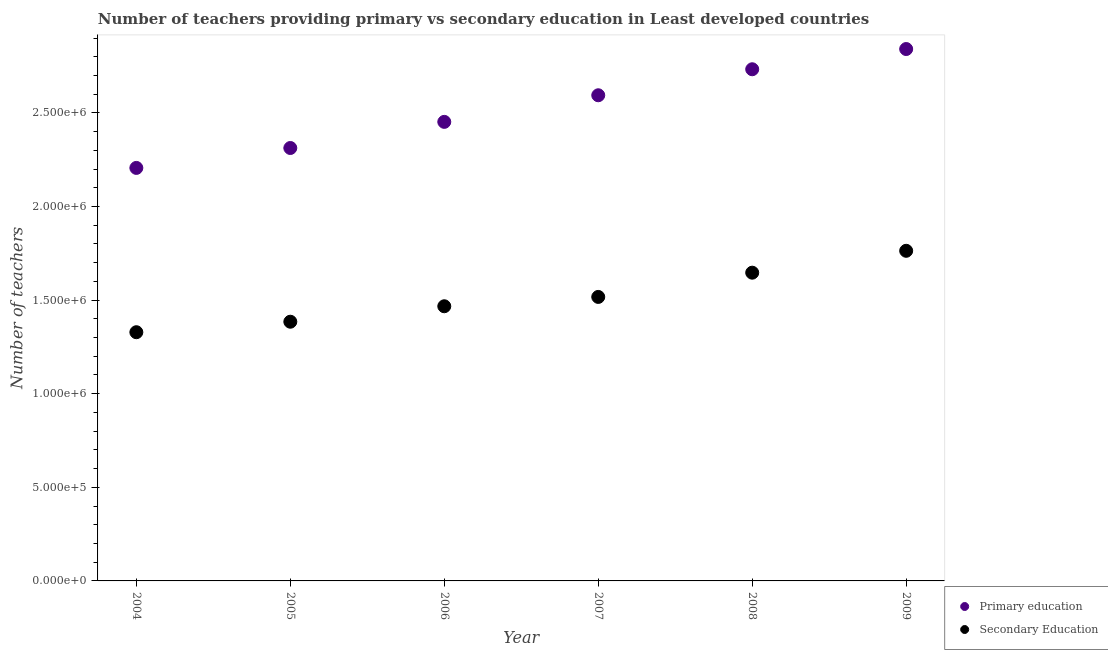How many different coloured dotlines are there?
Ensure brevity in your answer.  2. Is the number of dotlines equal to the number of legend labels?
Ensure brevity in your answer.  Yes. What is the number of primary teachers in 2006?
Ensure brevity in your answer.  2.45e+06. Across all years, what is the maximum number of secondary teachers?
Your answer should be compact. 1.76e+06. Across all years, what is the minimum number of primary teachers?
Your answer should be compact. 2.21e+06. What is the total number of secondary teachers in the graph?
Ensure brevity in your answer.  9.11e+06. What is the difference between the number of secondary teachers in 2004 and that in 2009?
Provide a succinct answer. -4.35e+05. What is the difference between the number of primary teachers in 2008 and the number of secondary teachers in 2004?
Keep it short and to the point. 1.40e+06. What is the average number of secondary teachers per year?
Your answer should be compact. 1.52e+06. In the year 2008, what is the difference between the number of primary teachers and number of secondary teachers?
Give a very brief answer. 1.09e+06. What is the ratio of the number of primary teachers in 2005 to that in 2008?
Make the answer very short. 0.85. Is the number of secondary teachers in 2004 less than that in 2009?
Your response must be concise. Yes. What is the difference between the highest and the second highest number of primary teachers?
Provide a succinct answer. 1.08e+05. What is the difference between the highest and the lowest number of secondary teachers?
Give a very brief answer. 4.35e+05. Is the sum of the number of secondary teachers in 2007 and 2009 greater than the maximum number of primary teachers across all years?
Provide a short and direct response. Yes. Is the number of secondary teachers strictly less than the number of primary teachers over the years?
Ensure brevity in your answer.  Yes. How many years are there in the graph?
Your answer should be very brief. 6. Are the values on the major ticks of Y-axis written in scientific E-notation?
Your response must be concise. Yes. Does the graph contain grids?
Offer a very short reply. No. What is the title of the graph?
Offer a very short reply. Number of teachers providing primary vs secondary education in Least developed countries. What is the label or title of the Y-axis?
Your response must be concise. Number of teachers. What is the Number of teachers of Primary education in 2004?
Keep it short and to the point. 2.21e+06. What is the Number of teachers in Secondary Education in 2004?
Your answer should be compact. 1.33e+06. What is the Number of teachers in Primary education in 2005?
Keep it short and to the point. 2.31e+06. What is the Number of teachers of Secondary Education in 2005?
Offer a terse response. 1.38e+06. What is the Number of teachers of Primary education in 2006?
Keep it short and to the point. 2.45e+06. What is the Number of teachers in Secondary Education in 2006?
Your answer should be compact. 1.47e+06. What is the Number of teachers in Primary education in 2007?
Offer a very short reply. 2.59e+06. What is the Number of teachers in Secondary Education in 2007?
Keep it short and to the point. 1.52e+06. What is the Number of teachers of Primary education in 2008?
Make the answer very short. 2.73e+06. What is the Number of teachers in Secondary Education in 2008?
Your response must be concise. 1.65e+06. What is the Number of teachers of Primary education in 2009?
Ensure brevity in your answer.  2.84e+06. What is the Number of teachers of Secondary Education in 2009?
Provide a succinct answer. 1.76e+06. Across all years, what is the maximum Number of teachers in Primary education?
Provide a short and direct response. 2.84e+06. Across all years, what is the maximum Number of teachers in Secondary Education?
Give a very brief answer. 1.76e+06. Across all years, what is the minimum Number of teachers in Primary education?
Ensure brevity in your answer.  2.21e+06. Across all years, what is the minimum Number of teachers in Secondary Education?
Your answer should be compact. 1.33e+06. What is the total Number of teachers of Primary education in the graph?
Keep it short and to the point. 1.51e+07. What is the total Number of teachers in Secondary Education in the graph?
Keep it short and to the point. 9.11e+06. What is the difference between the Number of teachers in Primary education in 2004 and that in 2005?
Your response must be concise. -1.06e+05. What is the difference between the Number of teachers in Secondary Education in 2004 and that in 2005?
Provide a short and direct response. -5.61e+04. What is the difference between the Number of teachers in Primary education in 2004 and that in 2006?
Keep it short and to the point. -2.46e+05. What is the difference between the Number of teachers in Secondary Education in 2004 and that in 2006?
Ensure brevity in your answer.  -1.39e+05. What is the difference between the Number of teachers of Primary education in 2004 and that in 2007?
Your answer should be very brief. -3.88e+05. What is the difference between the Number of teachers in Secondary Education in 2004 and that in 2007?
Provide a succinct answer. -1.88e+05. What is the difference between the Number of teachers in Primary education in 2004 and that in 2008?
Keep it short and to the point. -5.27e+05. What is the difference between the Number of teachers of Secondary Education in 2004 and that in 2008?
Ensure brevity in your answer.  -3.18e+05. What is the difference between the Number of teachers in Primary education in 2004 and that in 2009?
Offer a very short reply. -6.35e+05. What is the difference between the Number of teachers of Secondary Education in 2004 and that in 2009?
Keep it short and to the point. -4.35e+05. What is the difference between the Number of teachers of Primary education in 2005 and that in 2006?
Your response must be concise. -1.40e+05. What is the difference between the Number of teachers of Secondary Education in 2005 and that in 2006?
Keep it short and to the point. -8.26e+04. What is the difference between the Number of teachers in Primary education in 2005 and that in 2007?
Provide a short and direct response. -2.82e+05. What is the difference between the Number of teachers in Secondary Education in 2005 and that in 2007?
Provide a succinct answer. -1.32e+05. What is the difference between the Number of teachers of Primary education in 2005 and that in 2008?
Give a very brief answer. -4.21e+05. What is the difference between the Number of teachers in Secondary Education in 2005 and that in 2008?
Your response must be concise. -2.62e+05. What is the difference between the Number of teachers of Primary education in 2005 and that in 2009?
Your answer should be very brief. -5.29e+05. What is the difference between the Number of teachers of Secondary Education in 2005 and that in 2009?
Keep it short and to the point. -3.79e+05. What is the difference between the Number of teachers in Primary education in 2006 and that in 2007?
Give a very brief answer. -1.42e+05. What is the difference between the Number of teachers in Secondary Education in 2006 and that in 2007?
Offer a very short reply. -4.98e+04. What is the difference between the Number of teachers in Primary education in 2006 and that in 2008?
Your answer should be compact. -2.81e+05. What is the difference between the Number of teachers of Secondary Education in 2006 and that in 2008?
Your answer should be very brief. -1.79e+05. What is the difference between the Number of teachers of Primary education in 2006 and that in 2009?
Your answer should be very brief. -3.89e+05. What is the difference between the Number of teachers of Secondary Education in 2006 and that in 2009?
Make the answer very short. -2.96e+05. What is the difference between the Number of teachers of Primary education in 2007 and that in 2008?
Offer a terse response. -1.39e+05. What is the difference between the Number of teachers in Secondary Education in 2007 and that in 2008?
Ensure brevity in your answer.  -1.30e+05. What is the difference between the Number of teachers of Primary education in 2007 and that in 2009?
Give a very brief answer. -2.47e+05. What is the difference between the Number of teachers of Secondary Education in 2007 and that in 2009?
Provide a succinct answer. -2.46e+05. What is the difference between the Number of teachers of Primary education in 2008 and that in 2009?
Provide a succinct answer. -1.08e+05. What is the difference between the Number of teachers in Secondary Education in 2008 and that in 2009?
Your answer should be compact. -1.17e+05. What is the difference between the Number of teachers of Primary education in 2004 and the Number of teachers of Secondary Education in 2005?
Make the answer very short. 8.22e+05. What is the difference between the Number of teachers in Primary education in 2004 and the Number of teachers in Secondary Education in 2006?
Make the answer very short. 7.39e+05. What is the difference between the Number of teachers in Primary education in 2004 and the Number of teachers in Secondary Education in 2007?
Offer a very short reply. 6.89e+05. What is the difference between the Number of teachers in Primary education in 2004 and the Number of teachers in Secondary Education in 2008?
Keep it short and to the point. 5.60e+05. What is the difference between the Number of teachers of Primary education in 2004 and the Number of teachers of Secondary Education in 2009?
Offer a very short reply. 4.43e+05. What is the difference between the Number of teachers in Primary education in 2005 and the Number of teachers in Secondary Education in 2006?
Provide a short and direct response. 8.45e+05. What is the difference between the Number of teachers of Primary education in 2005 and the Number of teachers of Secondary Education in 2007?
Make the answer very short. 7.96e+05. What is the difference between the Number of teachers in Primary education in 2005 and the Number of teachers in Secondary Education in 2008?
Provide a succinct answer. 6.66e+05. What is the difference between the Number of teachers of Primary education in 2005 and the Number of teachers of Secondary Education in 2009?
Offer a very short reply. 5.49e+05. What is the difference between the Number of teachers in Primary education in 2006 and the Number of teachers in Secondary Education in 2007?
Provide a short and direct response. 9.35e+05. What is the difference between the Number of teachers in Primary education in 2006 and the Number of teachers in Secondary Education in 2008?
Provide a short and direct response. 8.06e+05. What is the difference between the Number of teachers of Primary education in 2006 and the Number of teachers of Secondary Education in 2009?
Make the answer very short. 6.89e+05. What is the difference between the Number of teachers of Primary education in 2007 and the Number of teachers of Secondary Education in 2008?
Provide a short and direct response. 9.48e+05. What is the difference between the Number of teachers of Primary education in 2007 and the Number of teachers of Secondary Education in 2009?
Provide a short and direct response. 8.31e+05. What is the difference between the Number of teachers of Primary education in 2008 and the Number of teachers of Secondary Education in 2009?
Provide a short and direct response. 9.70e+05. What is the average Number of teachers in Primary education per year?
Make the answer very short. 2.52e+06. What is the average Number of teachers of Secondary Education per year?
Your response must be concise. 1.52e+06. In the year 2004, what is the difference between the Number of teachers in Primary education and Number of teachers in Secondary Education?
Make the answer very short. 8.78e+05. In the year 2005, what is the difference between the Number of teachers in Primary education and Number of teachers in Secondary Education?
Your response must be concise. 9.28e+05. In the year 2006, what is the difference between the Number of teachers of Primary education and Number of teachers of Secondary Education?
Your answer should be compact. 9.85e+05. In the year 2007, what is the difference between the Number of teachers in Primary education and Number of teachers in Secondary Education?
Your answer should be compact. 1.08e+06. In the year 2008, what is the difference between the Number of teachers in Primary education and Number of teachers in Secondary Education?
Give a very brief answer. 1.09e+06. In the year 2009, what is the difference between the Number of teachers in Primary education and Number of teachers in Secondary Education?
Give a very brief answer. 1.08e+06. What is the ratio of the Number of teachers in Primary education in 2004 to that in 2005?
Keep it short and to the point. 0.95. What is the ratio of the Number of teachers of Secondary Education in 2004 to that in 2005?
Provide a succinct answer. 0.96. What is the ratio of the Number of teachers in Primary education in 2004 to that in 2006?
Your response must be concise. 0.9. What is the ratio of the Number of teachers in Secondary Education in 2004 to that in 2006?
Ensure brevity in your answer.  0.91. What is the ratio of the Number of teachers in Primary education in 2004 to that in 2007?
Ensure brevity in your answer.  0.85. What is the ratio of the Number of teachers in Secondary Education in 2004 to that in 2007?
Offer a terse response. 0.88. What is the ratio of the Number of teachers in Primary education in 2004 to that in 2008?
Provide a short and direct response. 0.81. What is the ratio of the Number of teachers in Secondary Education in 2004 to that in 2008?
Your answer should be compact. 0.81. What is the ratio of the Number of teachers in Primary education in 2004 to that in 2009?
Give a very brief answer. 0.78. What is the ratio of the Number of teachers of Secondary Education in 2004 to that in 2009?
Offer a terse response. 0.75. What is the ratio of the Number of teachers of Primary education in 2005 to that in 2006?
Make the answer very short. 0.94. What is the ratio of the Number of teachers of Secondary Education in 2005 to that in 2006?
Keep it short and to the point. 0.94. What is the ratio of the Number of teachers in Primary education in 2005 to that in 2007?
Your answer should be compact. 0.89. What is the ratio of the Number of teachers in Secondary Education in 2005 to that in 2007?
Your response must be concise. 0.91. What is the ratio of the Number of teachers of Primary education in 2005 to that in 2008?
Give a very brief answer. 0.85. What is the ratio of the Number of teachers of Secondary Education in 2005 to that in 2008?
Offer a very short reply. 0.84. What is the ratio of the Number of teachers of Primary education in 2005 to that in 2009?
Offer a very short reply. 0.81. What is the ratio of the Number of teachers of Secondary Education in 2005 to that in 2009?
Give a very brief answer. 0.79. What is the ratio of the Number of teachers in Primary education in 2006 to that in 2007?
Your answer should be very brief. 0.95. What is the ratio of the Number of teachers in Secondary Education in 2006 to that in 2007?
Offer a terse response. 0.97. What is the ratio of the Number of teachers of Primary education in 2006 to that in 2008?
Provide a succinct answer. 0.9. What is the ratio of the Number of teachers of Secondary Education in 2006 to that in 2008?
Give a very brief answer. 0.89. What is the ratio of the Number of teachers in Primary education in 2006 to that in 2009?
Give a very brief answer. 0.86. What is the ratio of the Number of teachers of Secondary Education in 2006 to that in 2009?
Make the answer very short. 0.83. What is the ratio of the Number of teachers in Primary education in 2007 to that in 2008?
Make the answer very short. 0.95. What is the ratio of the Number of teachers of Secondary Education in 2007 to that in 2008?
Your answer should be very brief. 0.92. What is the ratio of the Number of teachers in Primary education in 2007 to that in 2009?
Provide a succinct answer. 0.91. What is the ratio of the Number of teachers in Secondary Education in 2007 to that in 2009?
Your answer should be compact. 0.86. What is the ratio of the Number of teachers in Secondary Education in 2008 to that in 2009?
Ensure brevity in your answer.  0.93. What is the difference between the highest and the second highest Number of teachers of Primary education?
Provide a short and direct response. 1.08e+05. What is the difference between the highest and the second highest Number of teachers of Secondary Education?
Make the answer very short. 1.17e+05. What is the difference between the highest and the lowest Number of teachers in Primary education?
Offer a very short reply. 6.35e+05. What is the difference between the highest and the lowest Number of teachers of Secondary Education?
Offer a very short reply. 4.35e+05. 